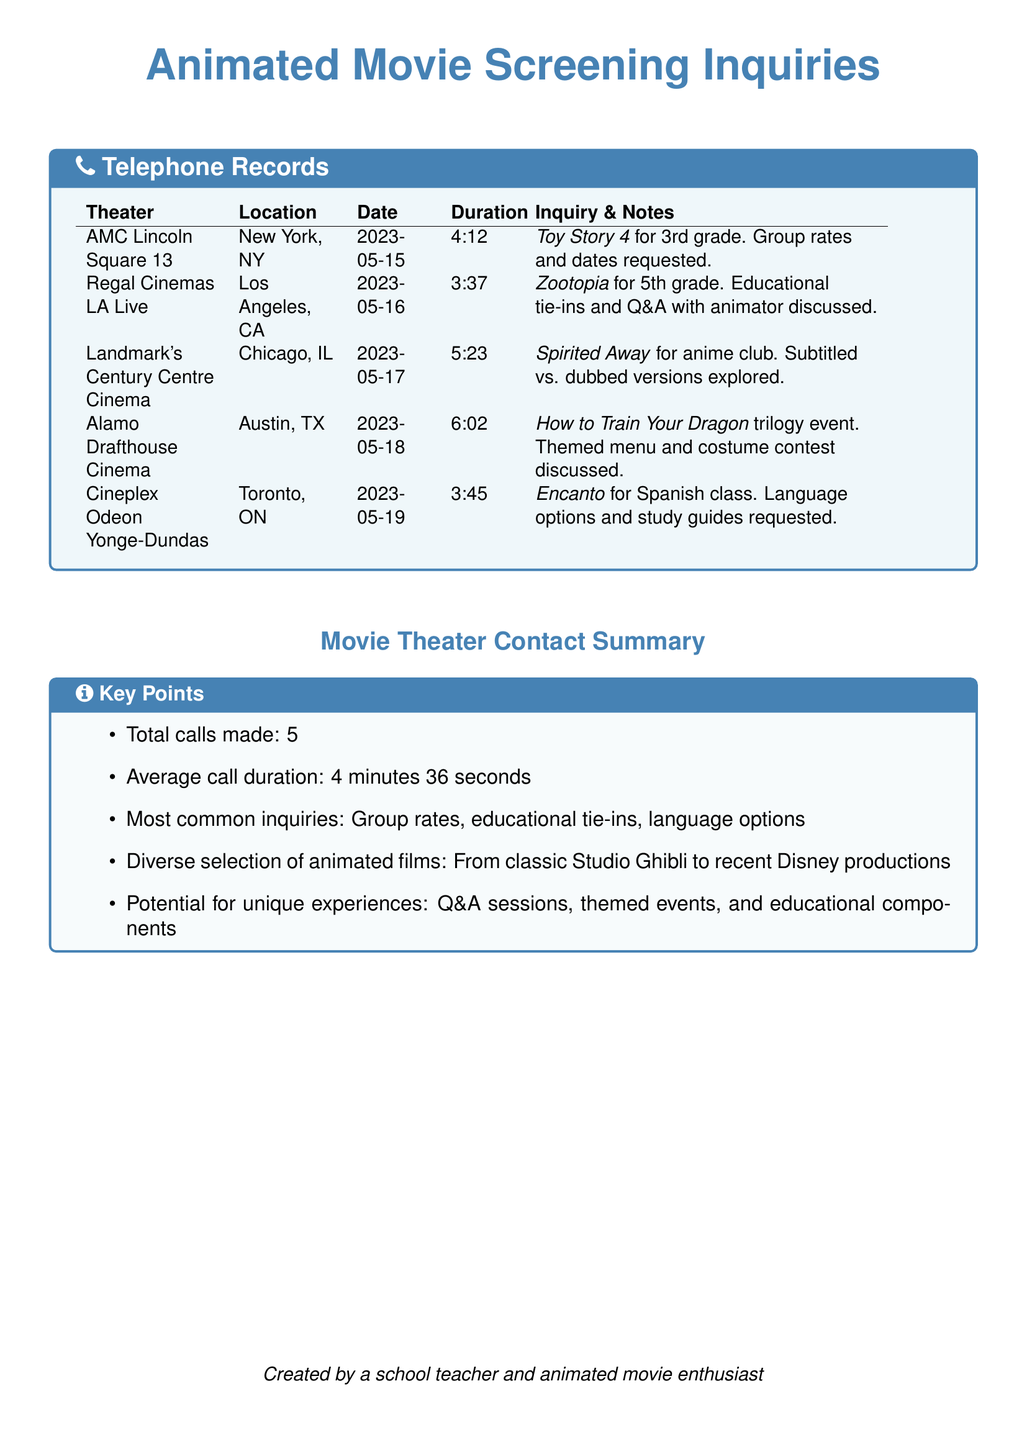what is the date of the call to AMC Lincoln Square 13? The date is listed in the table under the corresponding theater name.
Answer: 2023-05-15 how long was the inquiry for Zootopia? The duration is specified in the telephone records next to the date for Regal Cinemas LA Live.
Answer: 3:37 what animated film was inquired about for the Spanish class? This information is found in the notes section for Cineplex Odeon Yonge-Dundas in the table.
Answer: Encanto how many total calls were made? The total calls made is summarized in the key points section at the end of the document.
Answer: 5 which theater discussed a Q&A with an animator? This information can be found in the notes for the inquiry related to Zootopia, which mentions educational tie-ins and a Q&A.
Answer: Regal Cinemas LA Live what was the average call duration? The average duration is given in the key points section summarizing the call details.
Answer: 4 minutes 36 seconds which film was inquired about for the anime club? The film title can be found in the inquiry notes related to Landmark's Century Centre Cinema.
Answer: Spirited Away how many minutes was the longest call? The longest duration can be identified by comparing all recorded lengths in the table.
Answer: 6:02 what common inquiries were made? The common inquiries are listed in the key points section and summarize multiple inquiries across the calls.
Answer: Group rates, educational tie-ins, language options 